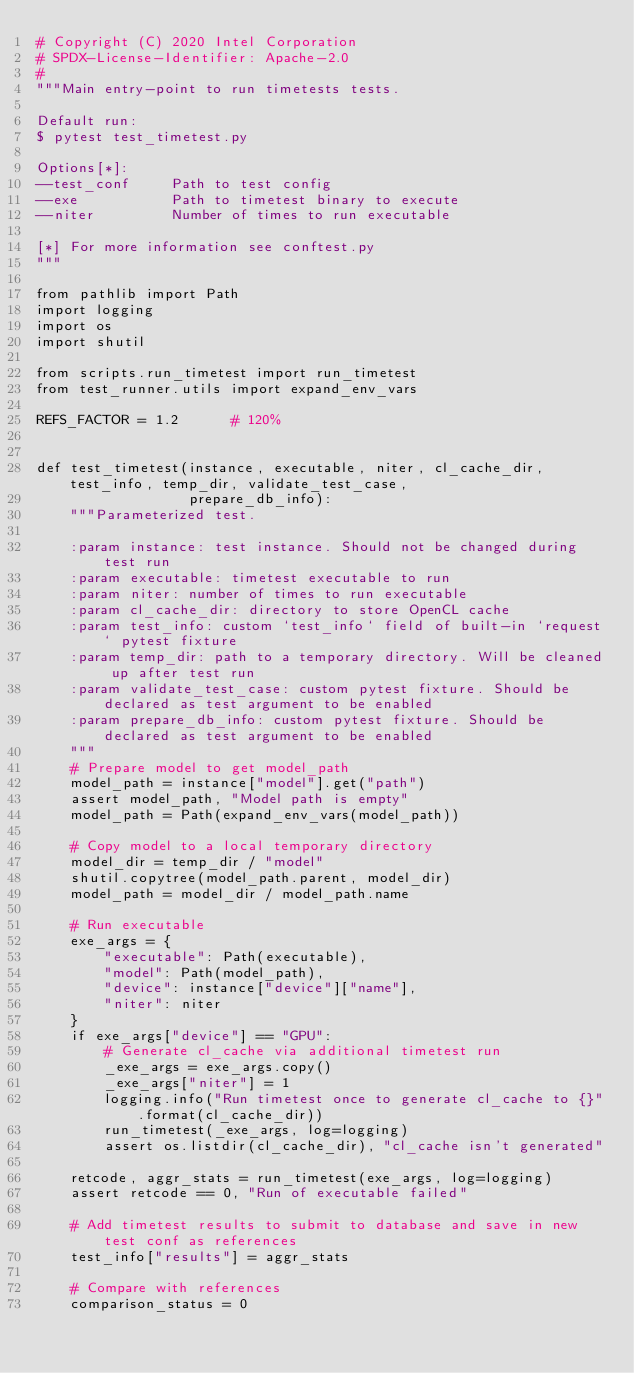Convert code to text. <code><loc_0><loc_0><loc_500><loc_500><_Python_># Copyright (C) 2020 Intel Corporation
# SPDX-License-Identifier: Apache-2.0
#
"""Main entry-point to run timetests tests.

Default run:
$ pytest test_timetest.py

Options[*]:
--test_conf     Path to test config
--exe           Path to timetest binary to execute
--niter         Number of times to run executable

[*] For more information see conftest.py
"""

from pathlib import Path
import logging
import os
import shutil

from scripts.run_timetest import run_timetest
from test_runner.utils import expand_env_vars

REFS_FACTOR = 1.2      # 120%


def test_timetest(instance, executable, niter, cl_cache_dir, test_info, temp_dir, validate_test_case,
                  prepare_db_info):
    """Parameterized test.

    :param instance: test instance. Should not be changed during test run
    :param executable: timetest executable to run
    :param niter: number of times to run executable
    :param cl_cache_dir: directory to store OpenCL cache
    :param test_info: custom `test_info` field of built-in `request` pytest fixture
    :param temp_dir: path to a temporary directory. Will be cleaned up after test run
    :param validate_test_case: custom pytest fixture. Should be declared as test argument to be enabled
    :param prepare_db_info: custom pytest fixture. Should be declared as test argument to be enabled
    """
    # Prepare model to get model_path
    model_path = instance["model"].get("path")
    assert model_path, "Model path is empty"
    model_path = Path(expand_env_vars(model_path))

    # Copy model to a local temporary directory
    model_dir = temp_dir / "model"
    shutil.copytree(model_path.parent, model_dir)
    model_path = model_dir / model_path.name

    # Run executable
    exe_args = {
        "executable": Path(executable),
        "model": Path(model_path),
        "device": instance["device"]["name"],
        "niter": niter
    }
    if exe_args["device"] == "GPU":
        # Generate cl_cache via additional timetest run
        _exe_args = exe_args.copy()
        _exe_args["niter"] = 1
        logging.info("Run timetest once to generate cl_cache to {}".format(cl_cache_dir))
        run_timetest(_exe_args, log=logging)
        assert os.listdir(cl_cache_dir), "cl_cache isn't generated"

    retcode, aggr_stats = run_timetest(exe_args, log=logging)
    assert retcode == 0, "Run of executable failed"

    # Add timetest results to submit to database and save in new test conf as references
    test_info["results"] = aggr_stats

    # Compare with references
    comparison_status = 0</code> 